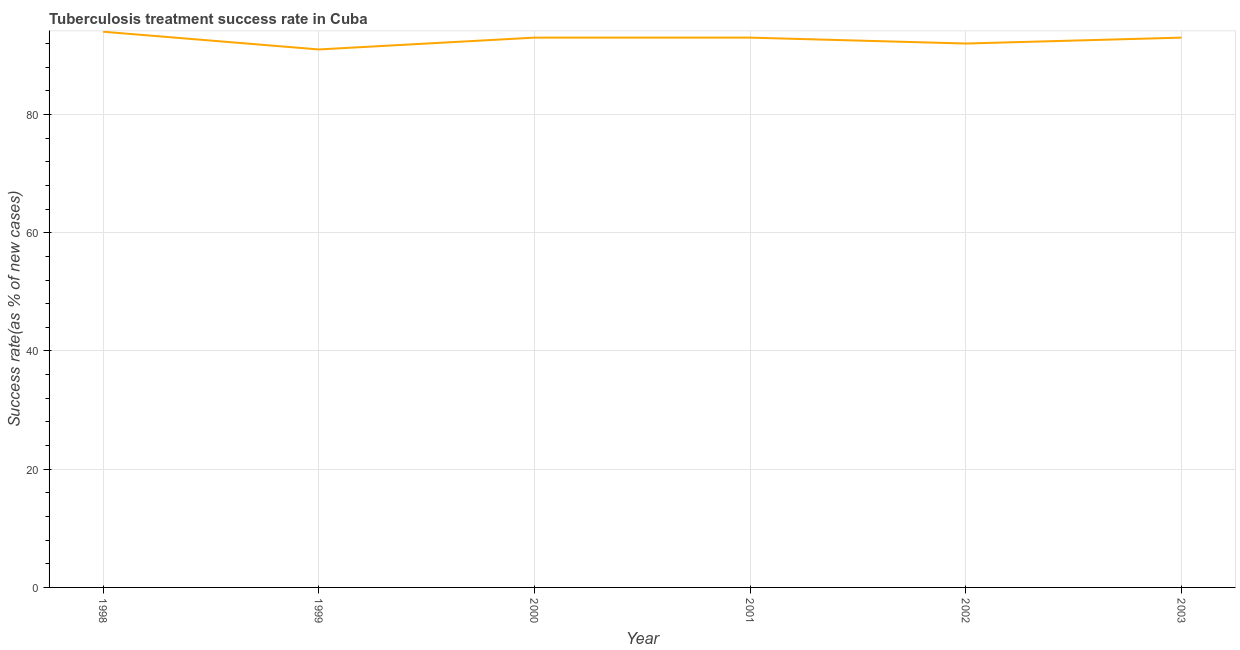What is the tuberculosis treatment success rate in 2003?
Your answer should be very brief. 93. Across all years, what is the maximum tuberculosis treatment success rate?
Ensure brevity in your answer.  94. Across all years, what is the minimum tuberculosis treatment success rate?
Offer a very short reply. 91. In which year was the tuberculosis treatment success rate maximum?
Keep it short and to the point. 1998. What is the sum of the tuberculosis treatment success rate?
Your answer should be compact. 556. What is the difference between the tuberculosis treatment success rate in 2001 and 2002?
Ensure brevity in your answer.  1. What is the average tuberculosis treatment success rate per year?
Offer a terse response. 92.67. What is the median tuberculosis treatment success rate?
Make the answer very short. 93. In how many years, is the tuberculosis treatment success rate greater than 68 %?
Provide a succinct answer. 6. Do a majority of the years between 2001 and 2003 (inclusive) have tuberculosis treatment success rate greater than 20 %?
Make the answer very short. Yes. What is the ratio of the tuberculosis treatment success rate in 1998 to that in 2000?
Your response must be concise. 1.01. Is the difference between the tuberculosis treatment success rate in 2000 and 2003 greater than the difference between any two years?
Provide a short and direct response. No. What is the difference between the highest and the second highest tuberculosis treatment success rate?
Your answer should be compact. 1. What is the difference between the highest and the lowest tuberculosis treatment success rate?
Your response must be concise. 3. In how many years, is the tuberculosis treatment success rate greater than the average tuberculosis treatment success rate taken over all years?
Provide a succinct answer. 4. Does the tuberculosis treatment success rate monotonically increase over the years?
Make the answer very short. No. How many lines are there?
Your answer should be compact. 1. What is the title of the graph?
Keep it short and to the point. Tuberculosis treatment success rate in Cuba. What is the label or title of the X-axis?
Offer a very short reply. Year. What is the label or title of the Y-axis?
Ensure brevity in your answer.  Success rate(as % of new cases). What is the Success rate(as % of new cases) in 1998?
Keep it short and to the point. 94. What is the Success rate(as % of new cases) in 1999?
Provide a short and direct response. 91. What is the Success rate(as % of new cases) in 2000?
Keep it short and to the point. 93. What is the Success rate(as % of new cases) of 2001?
Ensure brevity in your answer.  93. What is the Success rate(as % of new cases) in 2002?
Ensure brevity in your answer.  92. What is the Success rate(as % of new cases) in 2003?
Offer a terse response. 93. What is the difference between the Success rate(as % of new cases) in 1998 and 1999?
Your answer should be very brief. 3. What is the difference between the Success rate(as % of new cases) in 1999 and 2001?
Offer a very short reply. -2. What is the difference between the Success rate(as % of new cases) in 2000 and 2001?
Offer a very short reply. 0. What is the difference between the Success rate(as % of new cases) in 2001 and 2002?
Give a very brief answer. 1. What is the ratio of the Success rate(as % of new cases) in 1998 to that in 1999?
Give a very brief answer. 1.03. What is the ratio of the Success rate(as % of new cases) in 1998 to that in 2001?
Offer a terse response. 1.01. What is the ratio of the Success rate(as % of new cases) in 1998 to that in 2003?
Your answer should be very brief. 1.01. What is the ratio of the Success rate(as % of new cases) in 1999 to that in 2000?
Give a very brief answer. 0.98. What is the ratio of the Success rate(as % of new cases) in 2000 to that in 2001?
Your answer should be compact. 1. What is the ratio of the Success rate(as % of new cases) in 2000 to that in 2003?
Offer a terse response. 1. What is the ratio of the Success rate(as % of new cases) in 2001 to that in 2003?
Keep it short and to the point. 1. 